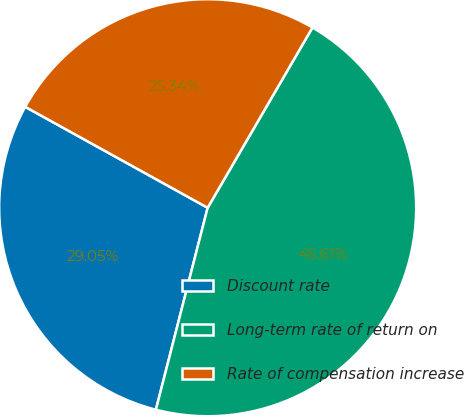Convert chart. <chart><loc_0><loc_0><loc_500><loc_500><pie_chart><fcel>Discount rate<fcel>Long-term rate of return on<fcel>Rate of compensation increase<nl><fcel>29.05%<fcel>45.61%<fcel>25.34%<nl></chart> 